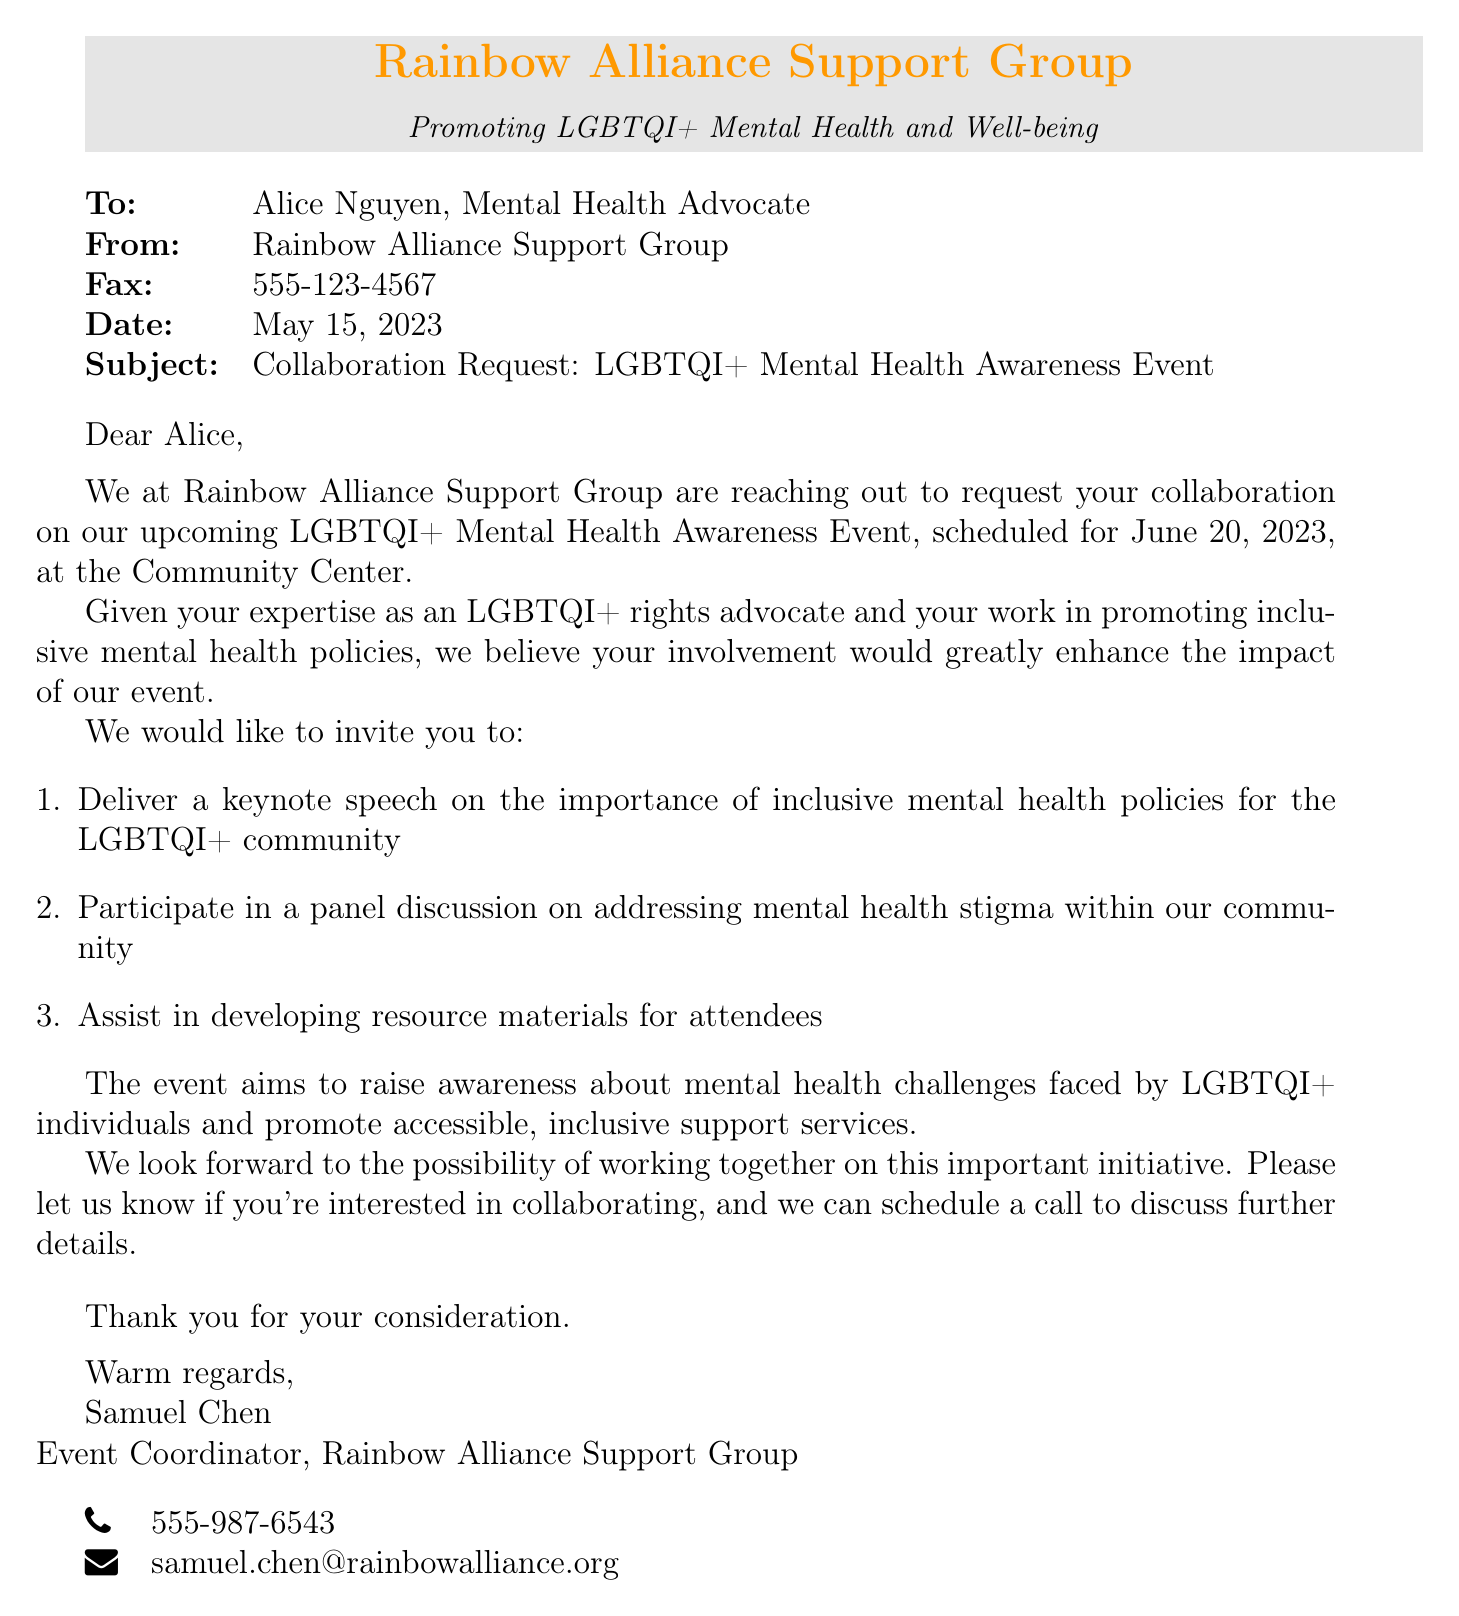What is the date of the event? The date of the event is mentioned in the document as June 20, 2023.
Answer: June 20, 2023 Who is the sender of the fax? The sender's name is provided at the top of the document, which is Samuel Chen.
Answer: Samuel Chen What role does Alice hold in the fax? The fax addresses Alice Nguyen, indicating that she is a Mental Health Advocate.
Answer: Mental Health Advocate What three tasks are proposed for collaboration? The document lists three tasks: delivering a keynote speech, participating in a panel discussion, and developing resource materials.
Answer: Keynote speech, panel discussion, resource materials What organization is the fax from? The fax is from the Rainbow Alliance Support Group, as mentioned in the header.
Answer: Rainbow Alliance Support Group What is the main theme of the event? The theme focuses on raising awareness about mental health challenges faced by LGBTQI+ individuals.
Answer: Mental health challenges faced by LGBTQI+ individuals How can Alice respond to the invitation? The document suggests that she can express her interest in a collaboration, and a call can be scheduled to discuss further details.
Answer: Schedule a call What is the contact email provided in the fax? The email address for communication is given in the document as samuel.chen@rainbowalliance.org.
Answer: samuel.chen@rainbowalliance.org 